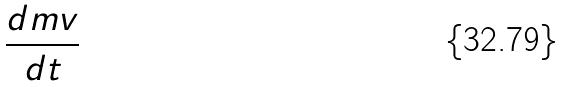<formula> <loc_0><loc_0><loc_500><loc_500>\frac { d m v } { d t }</formula> 